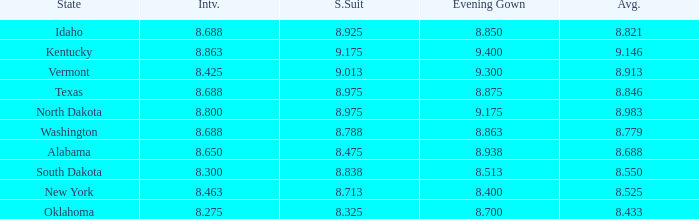What is the highest swimsuit score of the contestant with an evening gown larger than 9.175 and an interview score less than 8.425? None. 